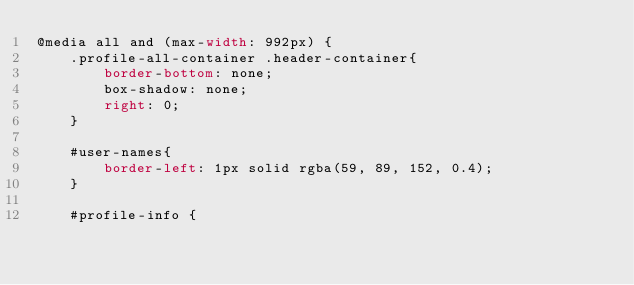Convert code to text. <code><loc_0><loc_0><loc_500><loc_500><_CSS_>@media all and (max-width: 992px) {
    .profile-all-container .header-container{
        border-bottom: none;
        box-shadow: none;
        right: 0;
    }

    #user-names{
        border-left: 1px solid rgba(59, 89, 152, 0.4);
    }

    #profile-info {</code> 